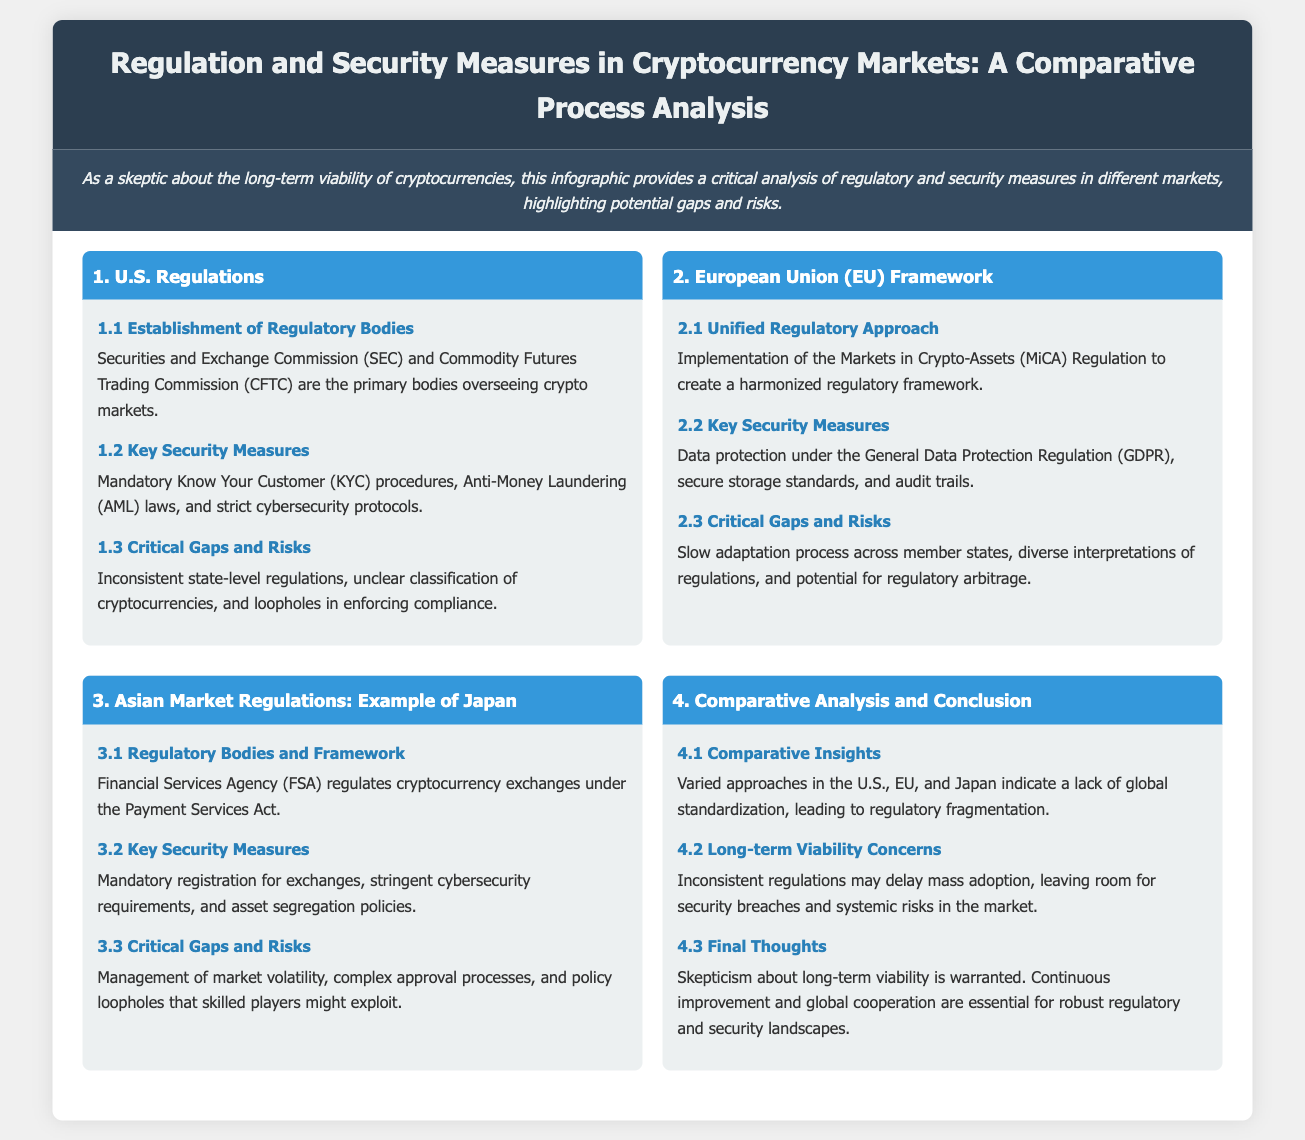What is the primary regulatory body in the U.S. overseeing crypto markets? The primary regulatory body in the U.S. overseeing crypto markets is the Securities and Exchange Commission (SEC).
Answer: Securities and Exchange Commission (SEC) What is the regulation adopted by the European Union for a unified approach? The regulation adopted by the European Union for a unified approach is the Markets in Crypto-Assets (MiCA) Regulation.
Answer: Markets in Crypto-Assets (MiCA) Regulation What key security measure is mandated under U.S. regulations? A key security measure mandated under U.S. regulations is Know Your Customer (KYC) procedures.
Answer: Know Your Customer (KYC) procedures What are the critical gaps identified in the Asian market regulations? The critical gaps identified in the Asian market regulations include management of market volatility and complex approval processes.
Answer: Management of market volatility, complex approval processes Which document highlights potential gaps and risks in cryptocurrency regulation? The document that highlights potential gaps and risks in cryptocurrency regulation is the infographic itself.
Answer: The infographic What is the primary regulatory body in Japan that oversees cryptocurrency exchanges? The primary regulatory body in Japan that oversees cryptocurrency exchanges is the Financial Services Agency (FSA).
Answer: Financial Services Agency (FSA) How does the document describe the long-term viability of cryptocurrencies? The document describes the long-term viability of cryptocurrencies as having concerns due to inconsistent regulations.
Answer: Long-term viability concerns What does the final section of the document emphasize as essential for regulatory improvements? The final section of the document emphasizes that continuous improvement and global cooperation are essential for regulatory improvements.
Answer: Continuous improvement and global cooperation What does the European Union's critical risk involve regarding regulations? The European Union's critical risk involves potential regulatory arbitrage due to diverse interpretations of regulations.
Answer: Potential for regulatory arbitrage 